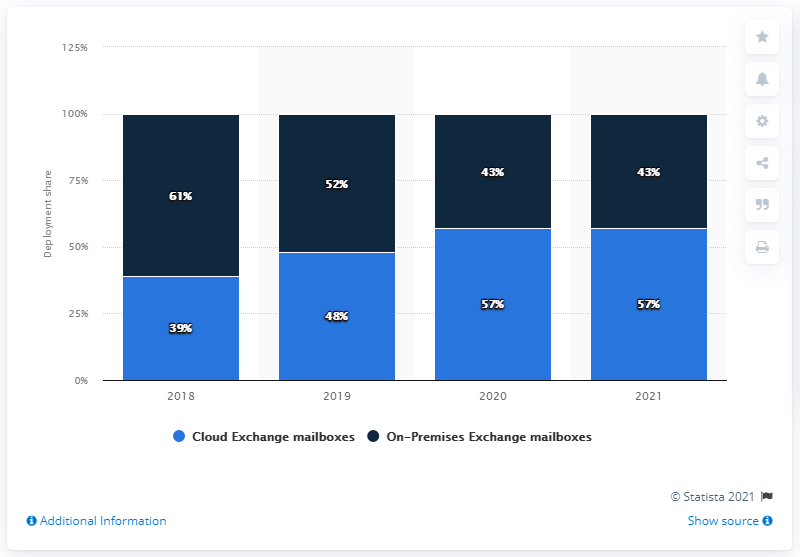Give some essential details in this illustration. In 2021, 57% of Microsoft Exchange Server users used cloud-based Exchange mailboxes. 